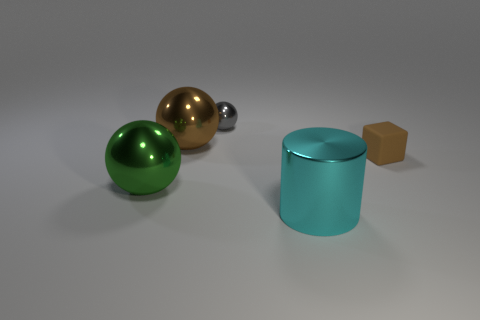Subtract 1 spheres. How many spheres are left? 2 Add 4 small brown balls. How many objects exist? 9 Subtract all cubes. How many objects are left? 4 Add 4 tiny matte blocks. How many tiny matte blocks are left? 5 Add 1 large brown balls. How many large brown balls exist? 2 Subtract 0 brown cylinders. How many objects are left? 5 Subtract all tiny matte things. Subtract all cyan metal cylinders. How many objects are left? 3 